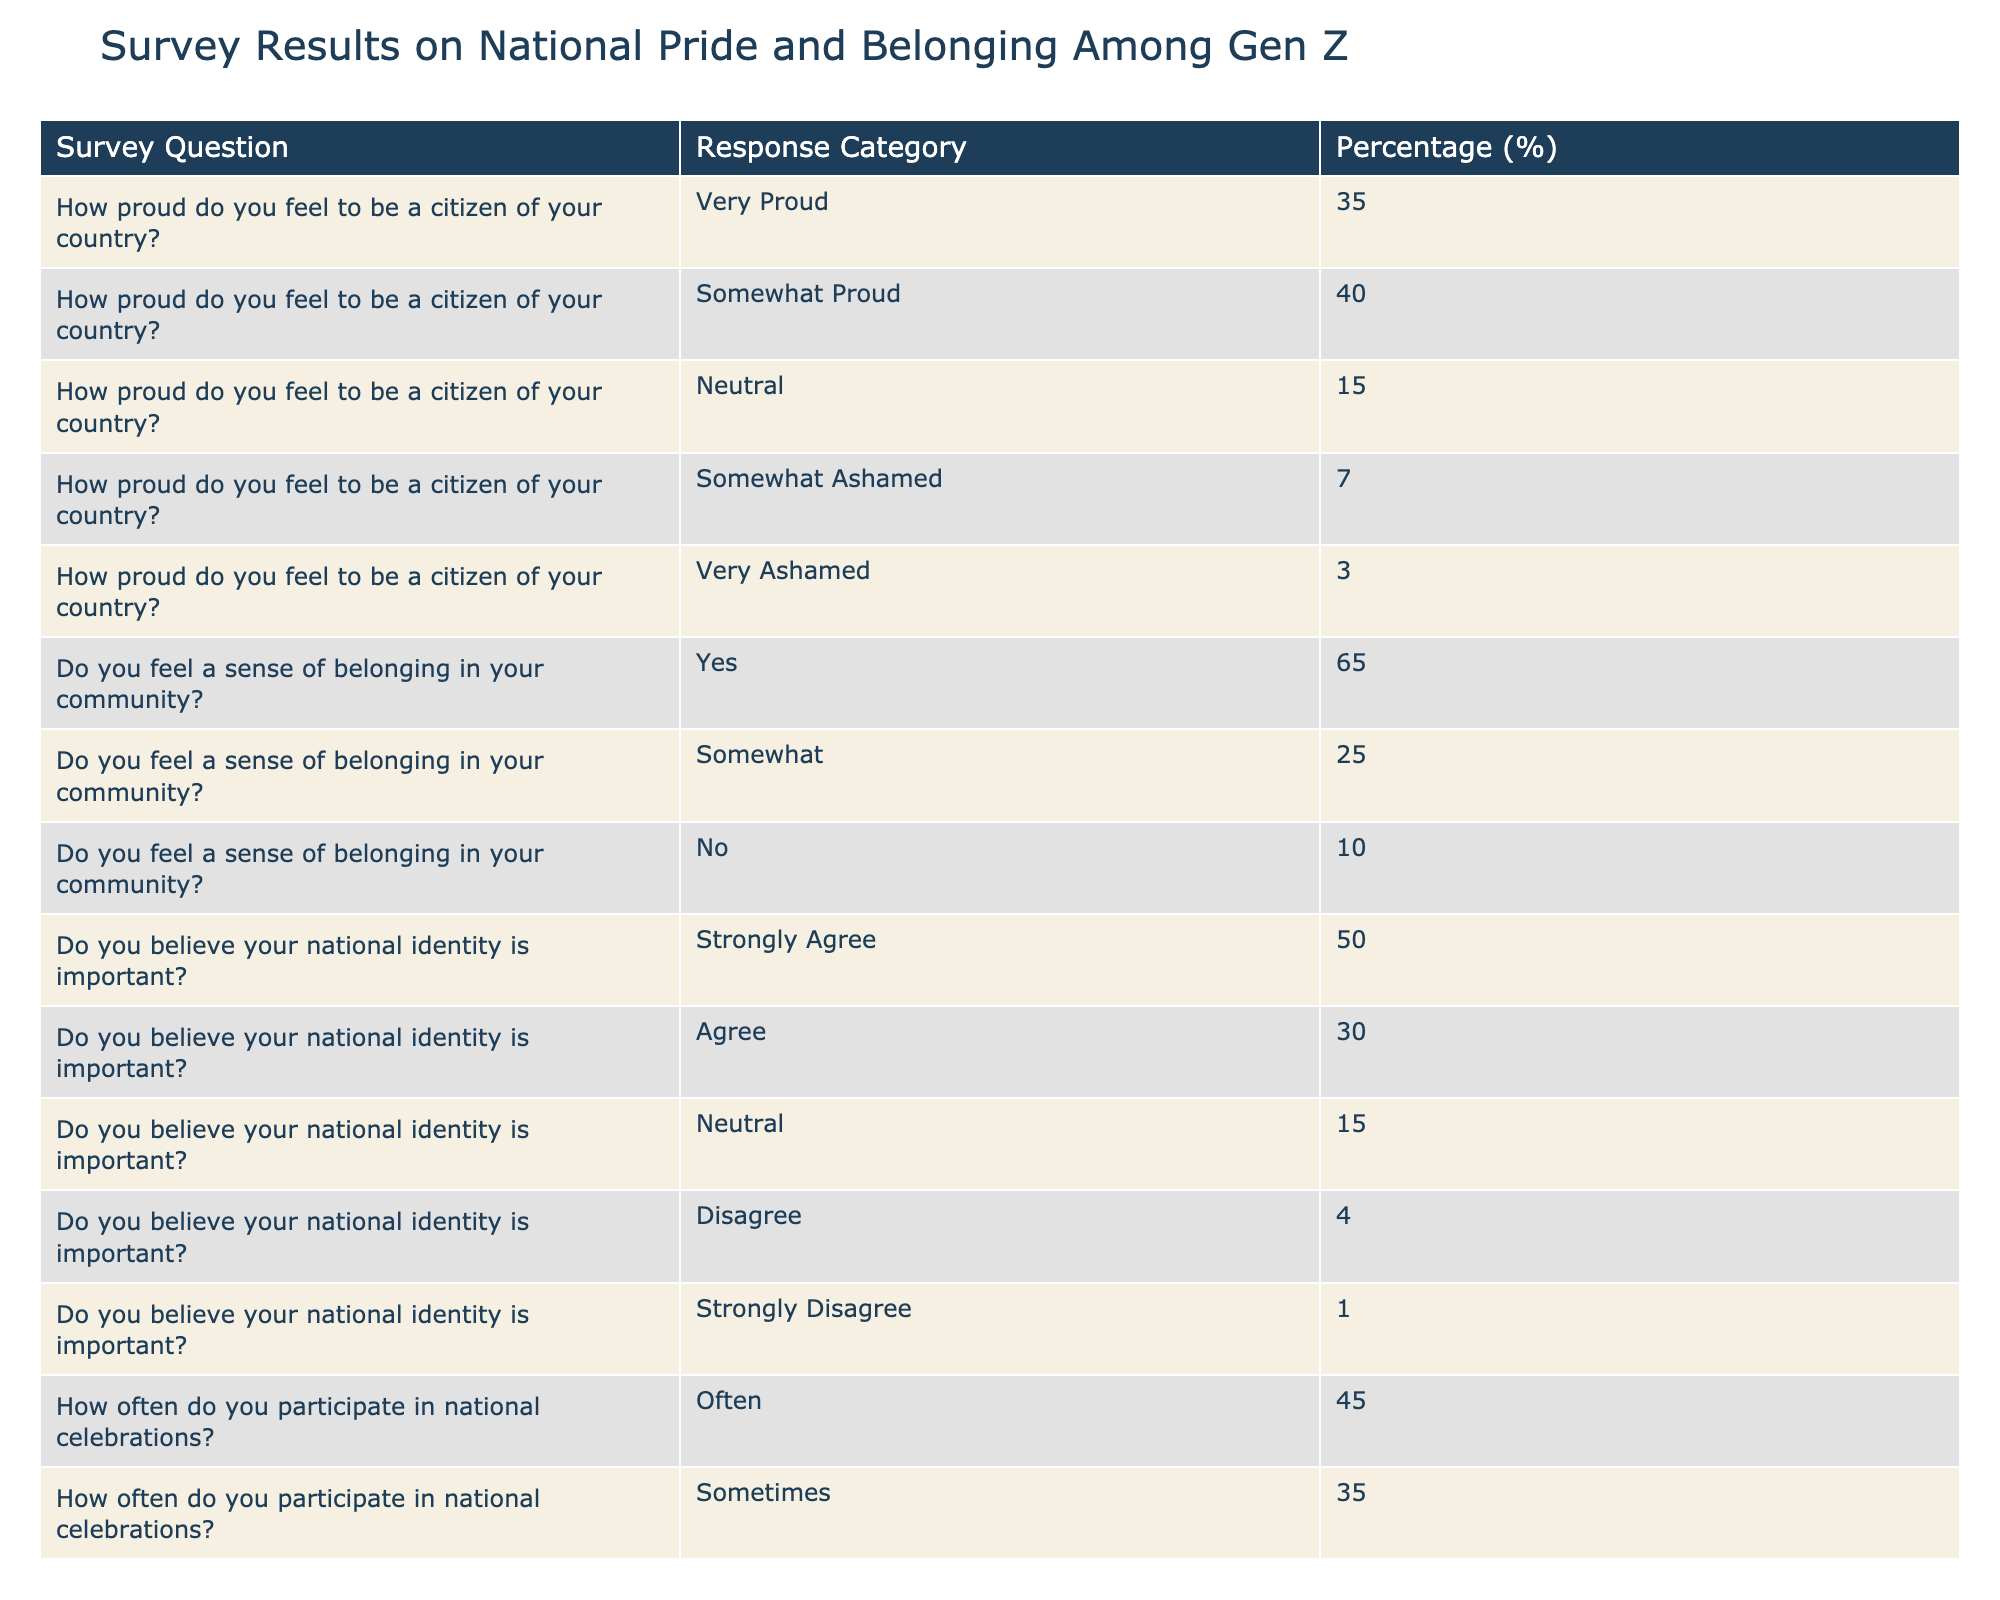What percentage of respondents feel very proud to be a citizen of their country? The table shows the response category "Very Proud" under the question "How proud do you feel to be a citizen of your country?" with a percentage of 35%.
Answer: 35% What percentage of Gen Z agrees or strongly agrees that their national identity is important? To find this, we need to sum the percentages for "Strongly Agree" (50%) and "Agree" (30%). So, 50 + 30 = 80%.
Answer: 80% Is there a higher percentage of respondents who feel a sense of belonging in their community or those who report feeling somewhat ashamed of their national identity? The percentage for "Yes" (65%) indicates a sense of belonging in the community, while "Somewhat Ashamed" is at 7%. Since 65% is greater than 7%, the answer is yes.
Answer: Yes What is the total percentage of respondents who feel neutral about their national pride? The percentage for "Neutral" under the question about national pride is 15%. Therefore, the total percentage of respondents who feel neutral is 15%.
Answer: 15% How often do Gen Z respondents participate in national celebrations, on average? The percentages for participation are: Often (45%), Sometimes (35%), Rarely (15%), and Never (5%). To find the average: (45 + 35 + 15 + 5) / 4 = 100 / 4 = 25%.
Answer: 25% What percentage of respondents disagree or strongly disagree about the importance of national identity? We need to consider "Disagree" (4%) and "Strongly Disagree" (1%). Adding them gives us 4 + 1 = 5%.
Answer: 5% Are there more respondents who feel somewhat proud than those who feel neutral about their national pride? The percentage for "Somewhat Proud" is 40% and for "Neutral" it's 15%. Since 40% is greater than 15%, the answer is yes.
Answer: Yes What is the difference in percentage between those feeling a strong sense of belonging and those feeling no sense of belonging at all? The percentage for "Yes" (65%) minus "No" (10%) gives 65 - 10 = 55%.
Answer: 55% 